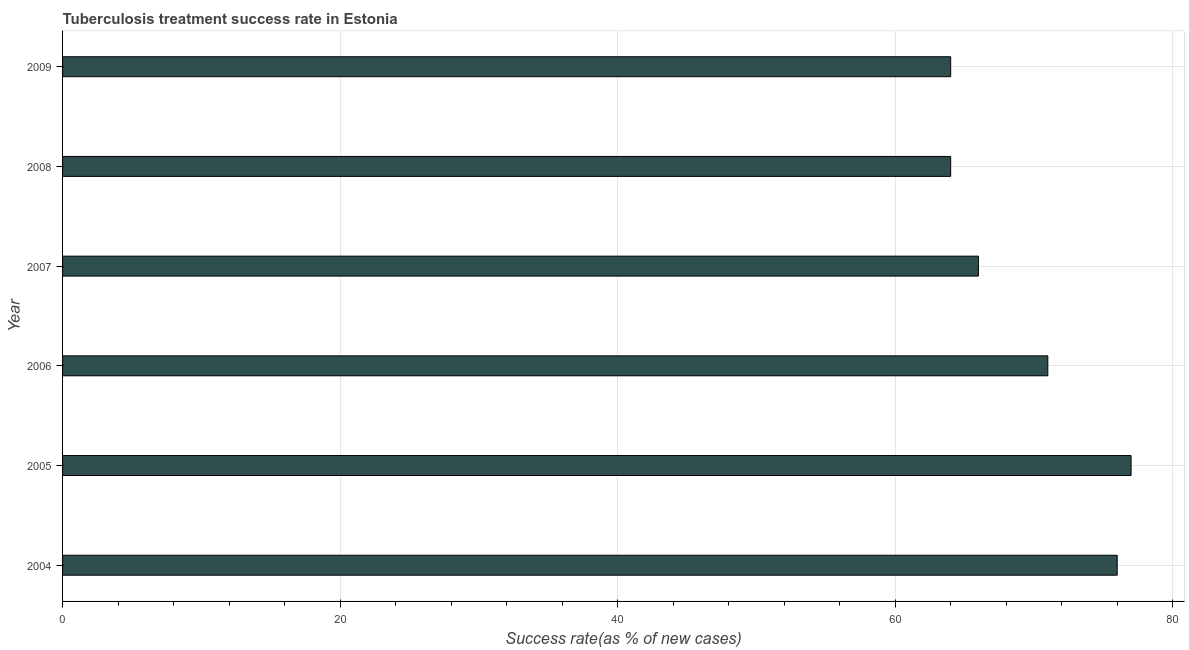Does the graph contain grids?
Your response must be concise. Yes. What is the title of the graph?
Your answer should be compact. Tuberculosis treatment success rate in Estonia. What is the label or title of the X-axis?
Your response must be concise. Success rate(as % of new cases). Across all years, what is the maximum tuberculosis treatment success rate?
Offer a terse response. 77. Across all years, what is the minimum tuberculosis treatment success rate?
Your response must be concise. 64. In which year was the tuberculosis treatment success rate maximum?
Provide a short and direct response. 2005. What is the sum of the tuberculosis treatment success rate?
Keep it short and to the point. 418. What is the average tuberculosis treatment success rate per year?
Your answer should be compact. 69. What is the median tuberculosis treatment success rate?
Offer a very short reply. 68.5. What is the ratio of the tuberculosis treatment success rate in 2005 to that in 2009?
Offer a very short reply. 1.2. Is the tuberculosis treatment success rate in 2006 less than that in 2008?
Offer a very short reply. No. What is the difference between the highest and the second highest tuberculosis treatment success rate?
Offer a terse response. 1. Is the sum of the tuberculosis treatment success rate in 2007 and 2009 greater than the maximum tuberculosis treatment success rate across all years?
Your answer should be compact. Yes. What is the difference between the highest and the lowest tuberculosis treatment success rate?
Provide a succinct answer. 13. In how many years, is the tuberculosis treatment success rate greater than the average tuberculosis treatment success rate taken over all years?
Offer a terse response. 3. How many years are there in the graph?
Provide a short and direct response. 6. What is the Success rate(as % of new cases) of 2006?
Ensure brevity in your answer.  71. What is the Success rate(as % of new cases) in 2007?
Make the answer very short. 66. What is the Success rate(as % of new cases) of 2008?
Make the answer very short. 64. What is the Success rate(as % of new cases) of 2009?
Ensure brevity in your answer.  64. What is the difference between the Success rate(as % of new cases) in 2004 and 2007?
Your answer should be compact. 10. What is the difference between the Success rate(as % of new cases) in 2004 and 2009?
Give a very brief answer. 12. What is the difference between the Success rate(as % of new cases) in 2005 and 2006?
Your response must be concise. 6. What is the difference between the Success rate(as % of new cases) in 2005 and 2007?
Your answer should be very brief. 11. What is the difference between the Success rate(as % of new cases) in 2005 and 2009?
Make the answer very short. 13. What is the ratio of the Success rate(as % of new cases) in 2004 to that in 2005?
Offer a very short reply. 0.99. What is the ratio of the Success rate(as % of new cases) in 2004 to that in 2006?
Offer a very short reply. 1.07. What is the ratio of the Success rate(as % of new cases) in 2004 to that in 2007?
Keep it short and to the point. 1.15. What is the ratio of the Success rate(as % of new cases) in 2004 to that in 2008?
Your answer should be very brief. 1.19. What is the ratio of the Success rate(as % of new cases) in 2004 to that in 2009?
Your answer should be very brief. 1.19. What is the ratio of the Success rate(as % of new cases) in 2005 to that in 2006?
Offer a terse response. 1.08. What is the ratio of the Success rate(as % of new cases) in 2005 to that in 2007?
Your answer should be compact. 1.17. What is the ratio of the Success rate(as % of new cases) in 2005 to that in 2008?
Give a very brief answer. 1.2. What is the ratio of the Success rate(as % of new cases) in 2005 to that in 2009?
Provide a short and direct response. 1.2. What is the ratio of the Success rate(as % of new cases) in 2006 to that in 2007?
Provide a short and direct response. 1.08. What is the ratio of the Success rate(as % of new cases) in 2006 to that in 2008?
Provide a short and direct response. 1.11. What is the ratio of the Success rate(as % of new cases) in 2006 to that in 2009?
Ensure brevity in your answer.  1.11. What is the ratio of the Success rate(as % of new cases) in 2007 to that in 2008?
Your answer should be very brief. 1.03. What is the ratio of the Success rate(as % of new cases) in 2007 to that in 2009?
Ensure brevity in your answer.  1.03. 